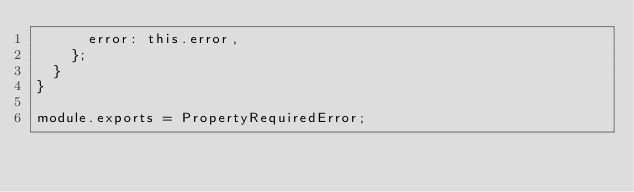<code> <loc_0><loc_0><loc_500><loc_500><_JavaScript_>      error: this.error,
    };
  }
}

module.exports = PropertyRequiredError;
</code> 